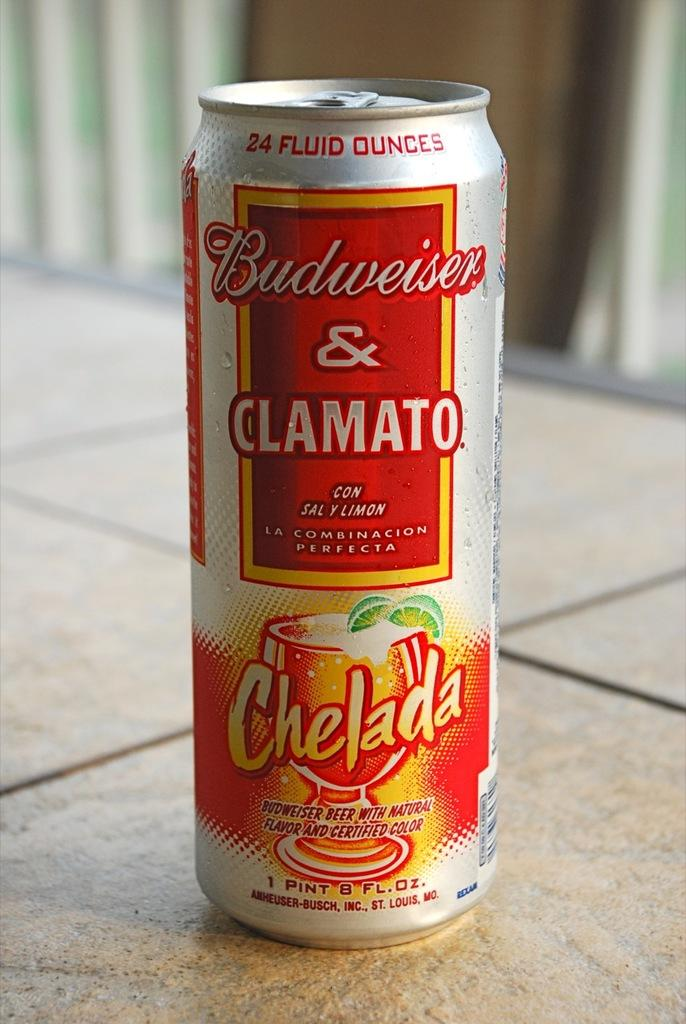<image>
Offer a succinct explanation of the picture presented. a can that has clamato written on it 